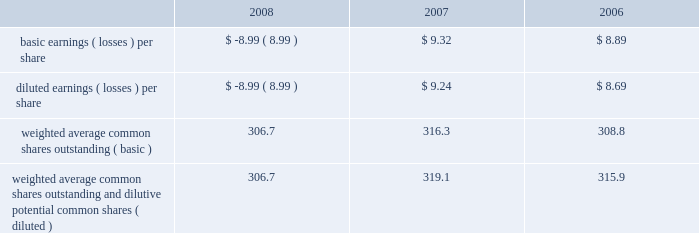Table of contents the company receives a foreign tax credit ( 201cftc 201d ) against its u.s .
Tax liability for foreign taxes paid by the company including payments from its separate account assets .
The separate account ftc is estimated for the current year using information from the most recent filed return , adjusted for the change in the allocation of separate account investments to the international equity markets during the current year .
The actual current year ftc can vary from the estimates due to actual ftcs passed through by the mutual funds .
The company recorded benefits of $ 16 , $ 11 and $ 17 related to separate account ftc in the years ended december 31 , 2008 , december 31 , 2007 and december 31 , 2006 , respectively .
These amounts included benefits related to true- ups of prior years 2019 tax returns of $ 4 , $ 0 and $ 7 in 2008 , 2007 and 2006 respectively .
The company 2019s unrecognized tax benefits increased by $ 15 during 2008 as a result of tax positions taken on the company 2019s 2007 tax return and expected to be taken on its 2008 tax return , bringing the total unrecognized tax benefits to $ 91 as of december 31 , 2008 .
This entire amount , if it were recognized , would affect the effective tax rate .
Earnings ( losses ) per common share the table represents earnings per common share data for the past three years : for additional information on earnings ( losses ) per common share see note 2 of notes to consolidated financial statements .
Outlooks the hartford provides projections and other forward-looking information in the 201coutlook 201d sections within md&a .
The 201coutlook 201d sections contain many forward-looking statements , particularly relating to the company 2019s future financial performance .
These forward-looking statements are estimates based on information currently available to the company , are made pursuant to the safe harbor provisions of the private securities litigation reform act of 1995 and are subject to the precautionary statements set forth in the introduction to md&a above .
Actual results are likely to differ , and in the past have differed , materially from those forecast by the company , depending on the outcome of various factors , including , but not limited to , those set forth in each 201coutlook 201d section and in item 1a , risk factors .
Outlook during 2008 , the company has been negatively impacted by conditions in the global financial markets and economic conditions in general .
As these conditions persist in 2009 , the company would anticipate that it would continue to be negatively impacted , including the effect of rating downgrades that have occurred and those that could occur in the future .
See risk factors in item 1a .
Retail in the long-term , management continues to believe the market for retirement products will expand as individuals increasingly save and plan for retirement .
Demographic trends suggest that as the 201cbaby boom 201d generation matures , a significant portion of the united states population will allocate a greater percentage of their disposable incomes to saving for their retirement years due to uncertainty surrounding the social security system and increases in average life expectancy .
Near-term , the industry and the company are experiencing lower variable annuity sales as a result of recent market turbulence and uncertainty in the u.s .
Financial system .
Current market pressures are also increasing the expected claim costs , the cost and volatility of hedging programs , and the level of capital needed to support living benefit guarantees .
Some companies have already begun to increase the price of their guaranteed living benefits and change the level of guarantees offered .
In 2009 , the company intends to adjust pricing levels and take certain actions to reduce the risks in its variable annuity product features in order to address the risks and costs associated with variable annuity benefit features in the current economic environment and explore other risk limiting techniques such as increased hedging or other reinsurance structures .
Competitor reaction , including the extent of competitor risk limiting strategies , is difficult to predict and may result in a decline in retail 2019s market share .
Significant declines in equity markets and increased equity market volatility are also likely to continue to impact the cost and effectiveness of our gmwb hedging program .
Continued equity market volatility could result in material losses in our hedging program .
For more information on the gmwb hedging program , see the equity risk management section within capital markets risk management .
During periods of volatile equity markets , policyholders may allocate more of their variable account assets to the fixed account options and fixed annuities may see increased deposits .
In the fourth quarter of 2008 , the company has seen an increase in fixed .
Weighted average common shares outstanding and dilutive potential common shares ( diluted ) 306.7 319.1 315.9 .
What is the net income reported in 2007 , ( in millions ) ? 
Computations: (316.3 * 9.32)
Answer: 2947.916. 